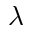Convert formula to latex. <formula><loc_0><loc_0><loc_500><loc_500>\lambda</formula> 